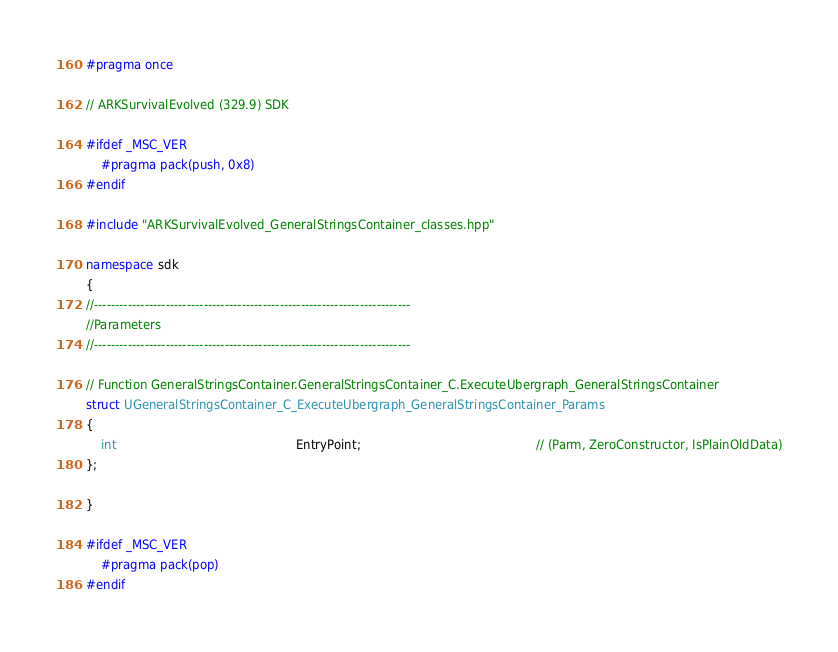Convert code to text. <code><loc_0><loc_0><loc_500><loc_500><_C++_>#pragma once

// ARKSurvivalEvolved (329.9) SDK

#ifdef _MSC_VER
	#pragma pack(push, 0x8)
#endif

#include "ARKSurvivalEvolved_GeneralStringsContainer_classes.hpp"

namespace sdk
{
//---------------------------------------------------------------------------
//Parameters
//---------------------------------------------------------------------------

// Function GeneralStringsContainer.GeneralStringsContainer_C.ExecuteUbergraph_GeneralStringsContainer
struct UGeneralStringsContainer_C_ExecuteUbergraph_GeneralStringsContainer_Params
{
	int                                                EntryPoint;                                               // (Parm, ZeroConstructor, IsPlainOldData)
};

}

#ifdef _MSC_VER
	#pragma pack(pop)
#endif
</code> 